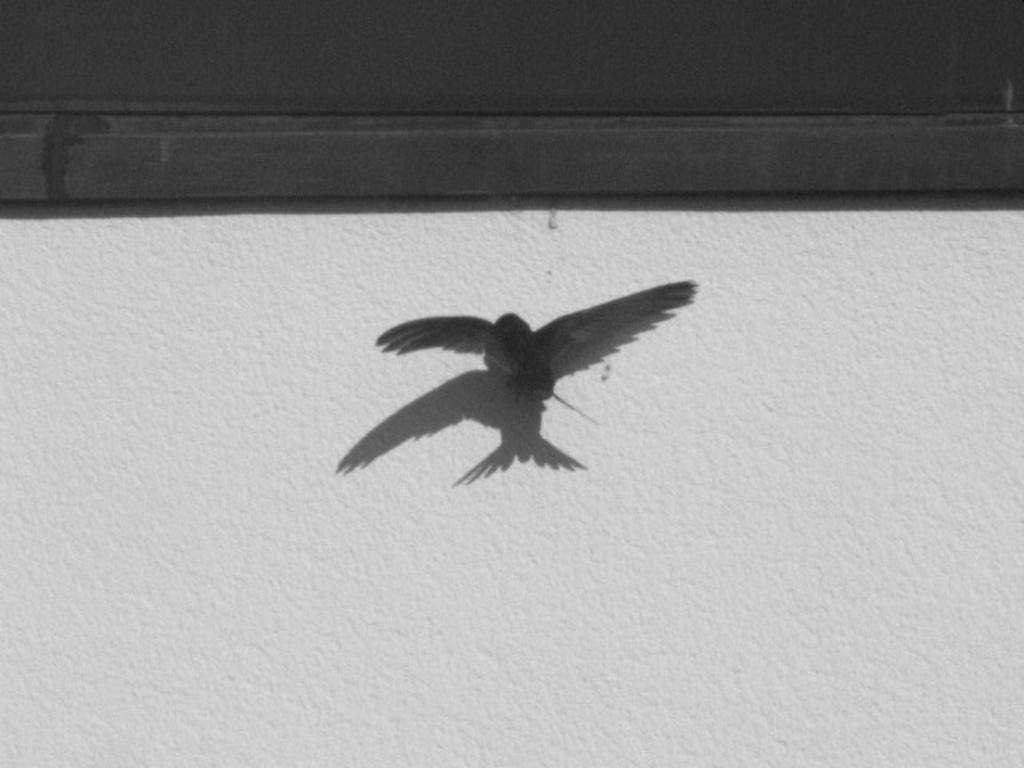How would you summarize this image in a sentence or two? In the image in the center we can see one bird flying. In the background there is a wall and some black color object. 